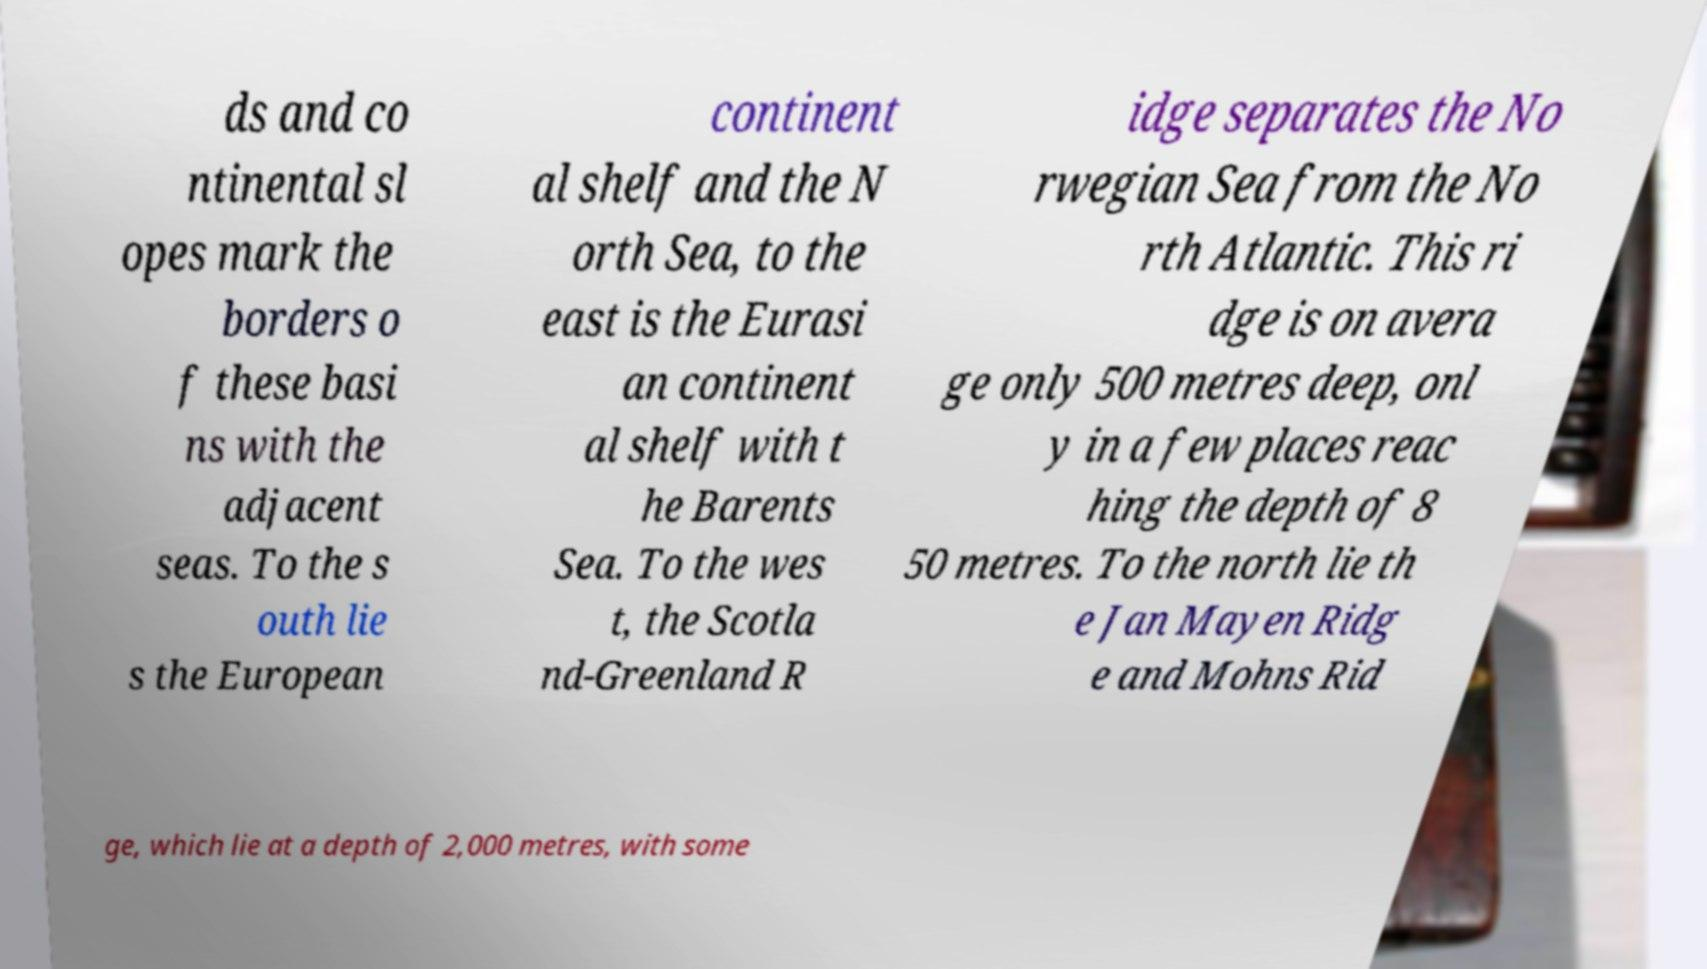Please identify and transcribe the text found in this image. ds and co ntinental sl opes mark the borders o f these basi ns with the adjacent seas. To the s outh lie s the European continent al shelf and the N orth Sea, to the east is the Eurasi an continent al shelf with t he Barents Sea. To the wes t, the Scotla nd-Greenland R idge separates the No rwegian Sea from the No rth Atlantic. This ri dge is on avera ge only 500 metres deep, onl y in a few places reac hing the depth of 8 50 metres. To the north lie th e Jan Mayen Ridg e and Mohns Rid ge, which lie at a depth of 2,000 metres, with some 